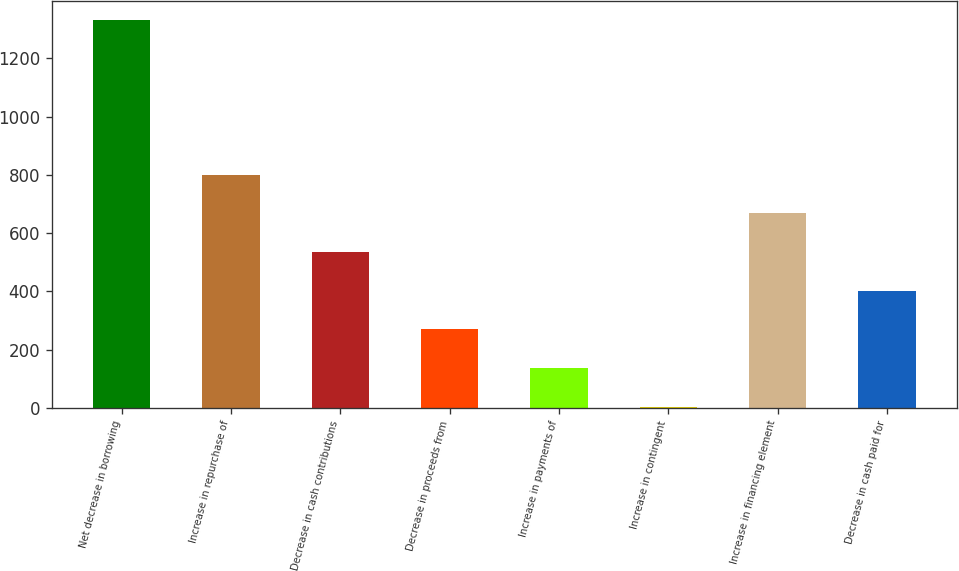<chart> <loc_0><loc_0><loc_500><loc_500><bar_chart><fcel>Net decrease in borrowing<fcel>Increase in repurchase of<fcel>Decrease in cash contributions<fcel>Decrease in proceeds from<fcel>Increase in payments of<fcel>Increase in contingent<fcel>Increase in financing element<fcel>Decrease in cash paid for<nl><fcel>1331<fcel>800.2<fcel>534.8<fcel>269.4<fcel>136.7<fcel>4<fcel>667.5<fcel>402.1<nl></chart> 